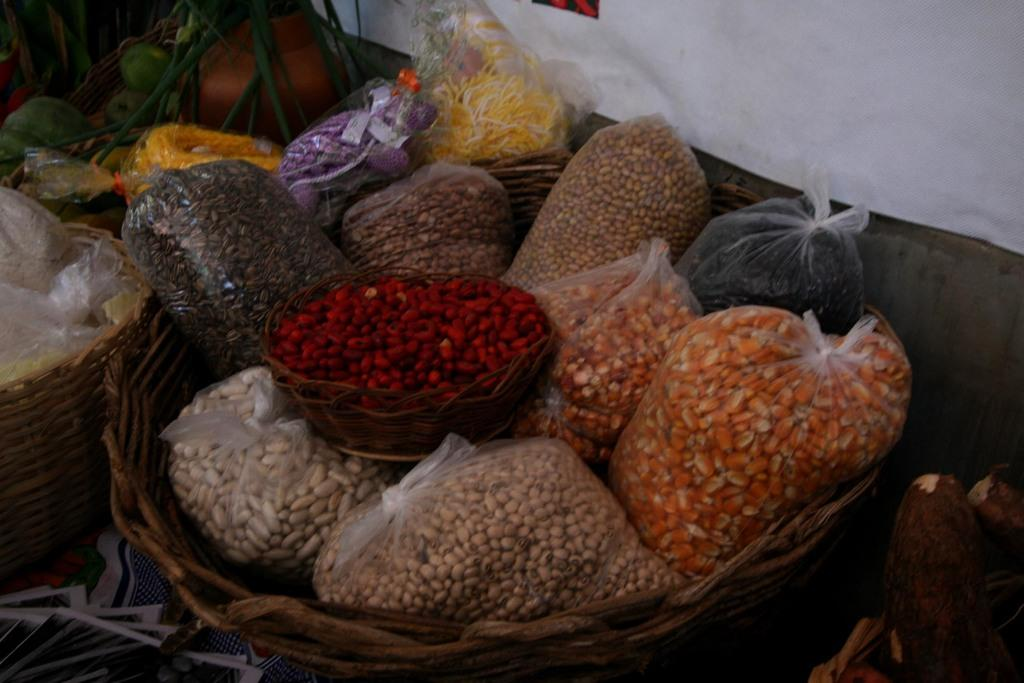What is in the basket that is visible in the image? There is a basket with grocery item covers in the image. Are there any other baskets in the image? Yes, there are other baskets with various items in the image. What type of lip product can be seen in the image? There is no lip product visible in the image; it features baskets with grocery item covers and other items. 